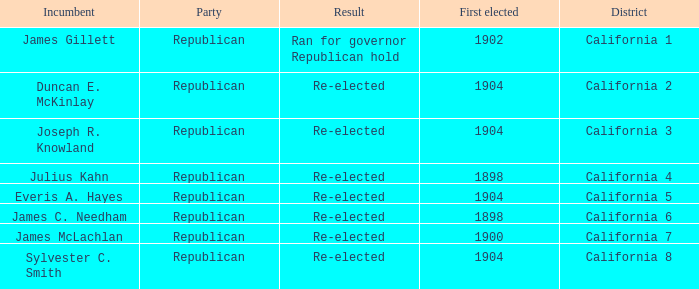What's the highest First Elected with a Result of Re-elected and DIstrict of California 5? 1904.0. 